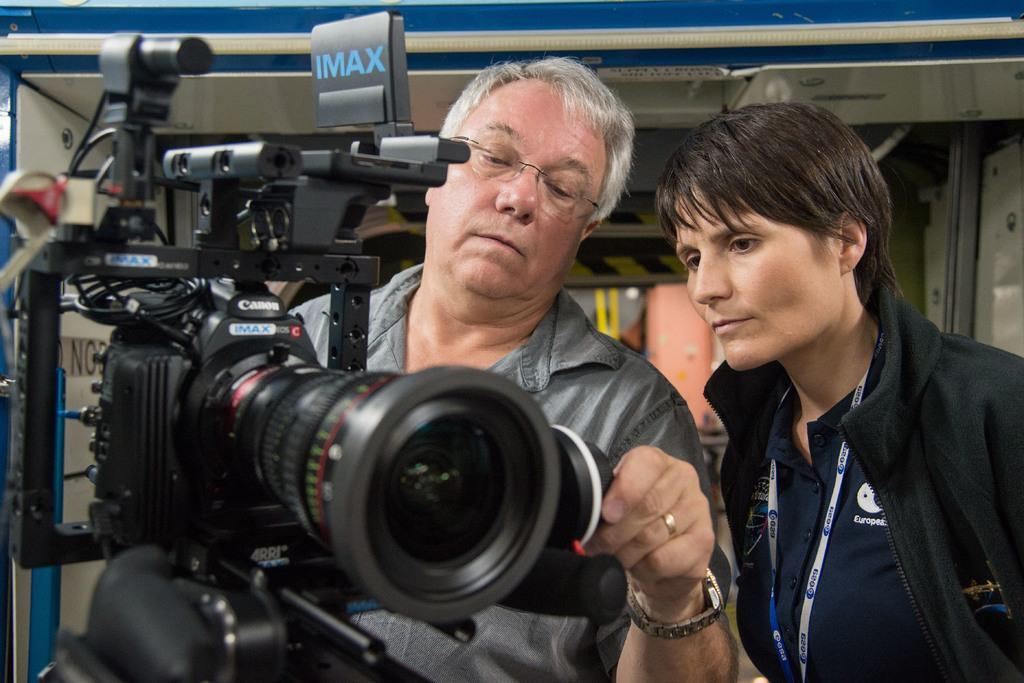What is the man in the image holding? The man is holding a camera in the image. Who else is present in the image? There is a woman in the image. What is the woman doing in the image? The woman is watching the man with the camera. How many birds can be seen on the plate in the image? There is no plate or birds present in the image. What type of ducks are swimming in the background of the image? There are no ducks or background visible in the image. 